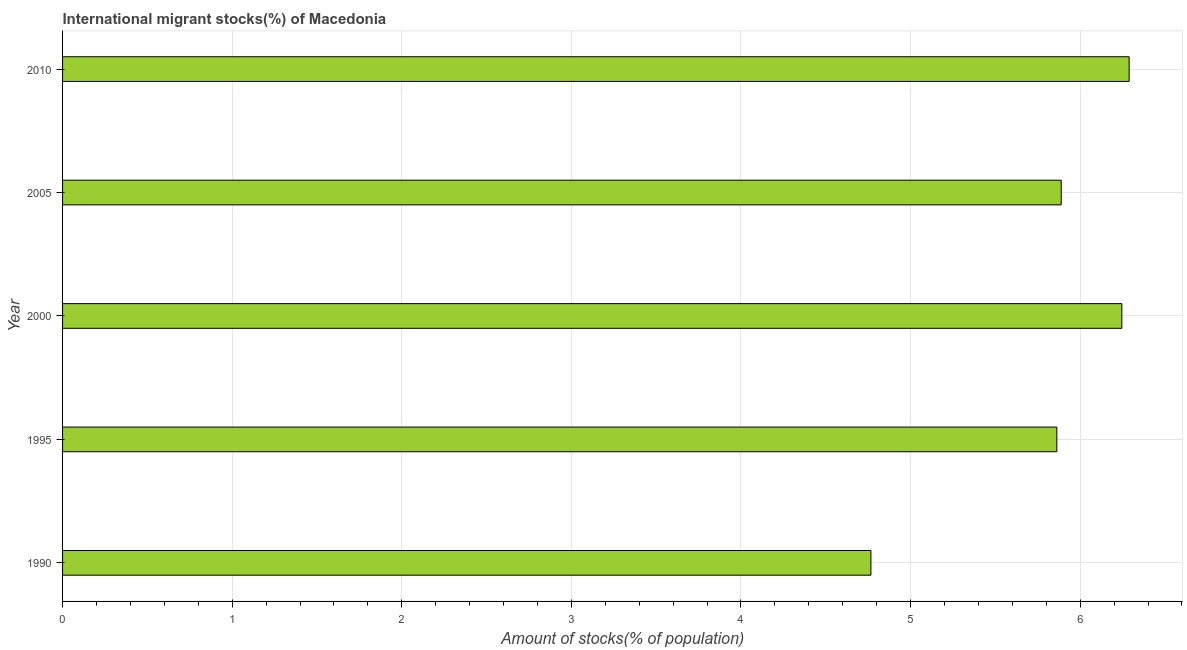Does the graph contain any zero values?
Give a very brief answer. No. What is the title of the graph?
Provide a succinct answer. International migrant stocks(%) of Macedonia. What is the label or title of the X-axis?
Make the answer very short. Amount of stocks(% of population). What is the label or title of the Y-axis?
Ensure brevity in your answer.  Year. What is the number of international migrant stocks in 1990?
Give a very brief answer. 4.77. Across all years, what is the maximum number of international migrant stocks?
Make the answer very short. 6.29. Across all years, what is the minimum number of international migrant stocks?
Make the answer very short. 4.77. In which year was the number of international migrant stocks minimum?
Your response must be concise. 1990. What is the sum of the number of international migrant stocks?
Give a very brief answer. 29.05. What is the difference between the number of international migrant stocks in 1990 and 2010?
Offer a very short reply. -1.52. What is the average number of international migrant stocks per year?
Your answer should be very brief. 5.81. What is the median number of international migrant stocks?
Provide a short and direct response. 5.89. In how many years, is the number of international migrant stocks greater than 5.4 %?
Offer a very short reply. 4. Do a majority of the years between 1995 and 2010 (inclusive) have number of international migrant stocks greater than 6.2 %?
Offer a terse response. No. What is the ratio of the number of international migrant stocks in 2000 to that in 2010?
Make the answer very short. 0.99. Is the difference between the number of international migrant stocks in 2000 and 2005 greater than the difference between any two years?
Your response must be concise. No. What is the difference between the highest and the second highest number of international migrant stocks?
Make the answer very short. 0.04. Is the sum of the number of international migrant stocks in 1995 and 2005 greater than the maximum number of international migrant stocks across all years?
Your answer should be compact. Yes. What is the difference between the highest and the lowest number of international migrant stocks?
Your answer should be very brief. 1.52. In how many years, is the number of international migrant stocks greater than the average number of international migrant stocks taken over all years?
Give a very brief answer. 4. How many bars are there?
Offer a very short reply. 5. What is the difference between two consecutive major ticks on the X-axis?
Your answer should be very brief. 1. Are the values on the major ticks of X-axis written in scientific E-notation?
Make the answer very short. No. What is the Amount of stocks(% of population) in 1990?
Ensure brevity in your answer.  4.77. What is the Amount of stocks(% of population) in 1995?
Offer a terse response. 5.86. What is the Amount of stocks(% of population) of 2000?
Keep it short and to the point. 6.25. What is the Amount of stocks(% of population) in 2005?
Your response must be concise. 5.89. What is the Amount of stocks(% of population) in 2010?
Provide a short and direct response. 6.29. What is the difference between the Amount of stocks(% of population) in 1990 and 1995?
Your answer should be compact. -1.1. What is the difference between the Amount of stocks(% of population) in 1990 and 2000?
Your answer should be very brief. -1.48. What is the difference between the Amount of stocks(% of population) in 1990 and 2005?
Ensure brevity in your answer.  -1.12. What is the difference between the Amount of stocks(% of population) in 1990 and 2010?
Your answer should be very brief. -1.52. What is the difference between the Amount of stocks(% of population) in 1995 and 2000?
Provide a short and direct response. -0.38. What is the difference between the Amount of stocks(% of population) in 1995 and 2005?
Your response must be concise. -0.03. What is the difference between the Amount of stocks(% of population) in 1995 and 2010?
Your answer should be compact. -0.43. What is the difference between the Amount of stocks(% of population) in 2000 and 2005?
Keep it short and to the point. 0.36. What is the difference between the Amount of stocks(% of population) in 2000 and 2010?
Provide a succinct answer. -0.04. What is the difference between the Amount of stocks(% of population) in 2005 and 2010?
Keep it short and to the point. -0.4. What is the ratio of the Amount of stocks(% of population) in 1990 to that in 1995?
Your response must be concise. 0.81. What is the ratio of the Amount of stocks(% of population) in 1990 to that in 2000?
Keep it short and to the point. 0.76. What is the ratio of the Amount of stocks(% of population) in 1990 to that in 2005?
Give a very brief answer. 0.81. What is the ratio of the Amount of stocks(% of population) in 1990 to that in 2010?
Make the answer very short. 0.76. What is the ratio of the Amount of stocks(% of population) in 1995 to that in 2000?
Offer a terse response. 0.94. What is the ratio of the Amount of stocks(% of population) in 1995 to that in 2005?
Your answer should be compact. 1. What is the ratio of the Amount of stocks(% of population) in 1995 to that in 2010?
Your answer should be compact. 0.93. What is the ratio of the Amount of stocks(% of population) in 2000 to that in 2005?
Provide a short and direct response. 1.06. What is the ratio of the Amount of stocks(% of population) in 2000 to that in 2010?
Offer a very short reply. 0.99. What is the ratio of the Amount of stocks(% of population) in 2005 to that in 2010?
Offer a very short reply. 0.94. 